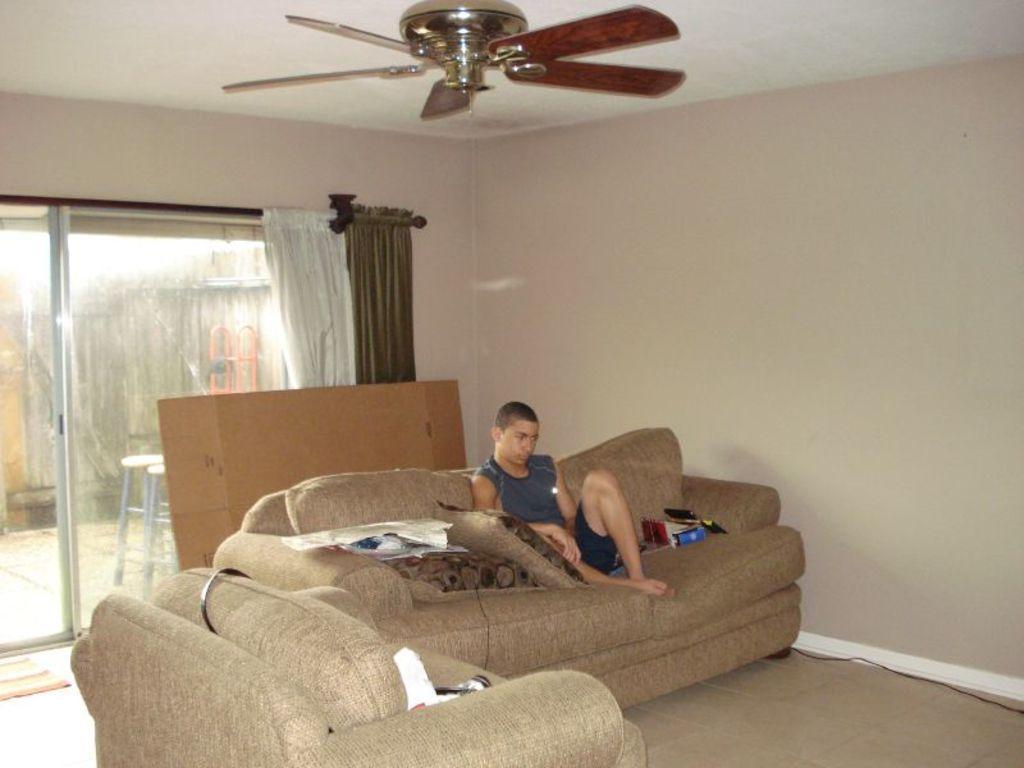In one or two sentences, can you explain what this image depicts? In this image i can see the sofa and one person sitting on it and few objects, behind that i can see one object, near that there is a glass door with the curtain and the chair, at the top there is a fan. 